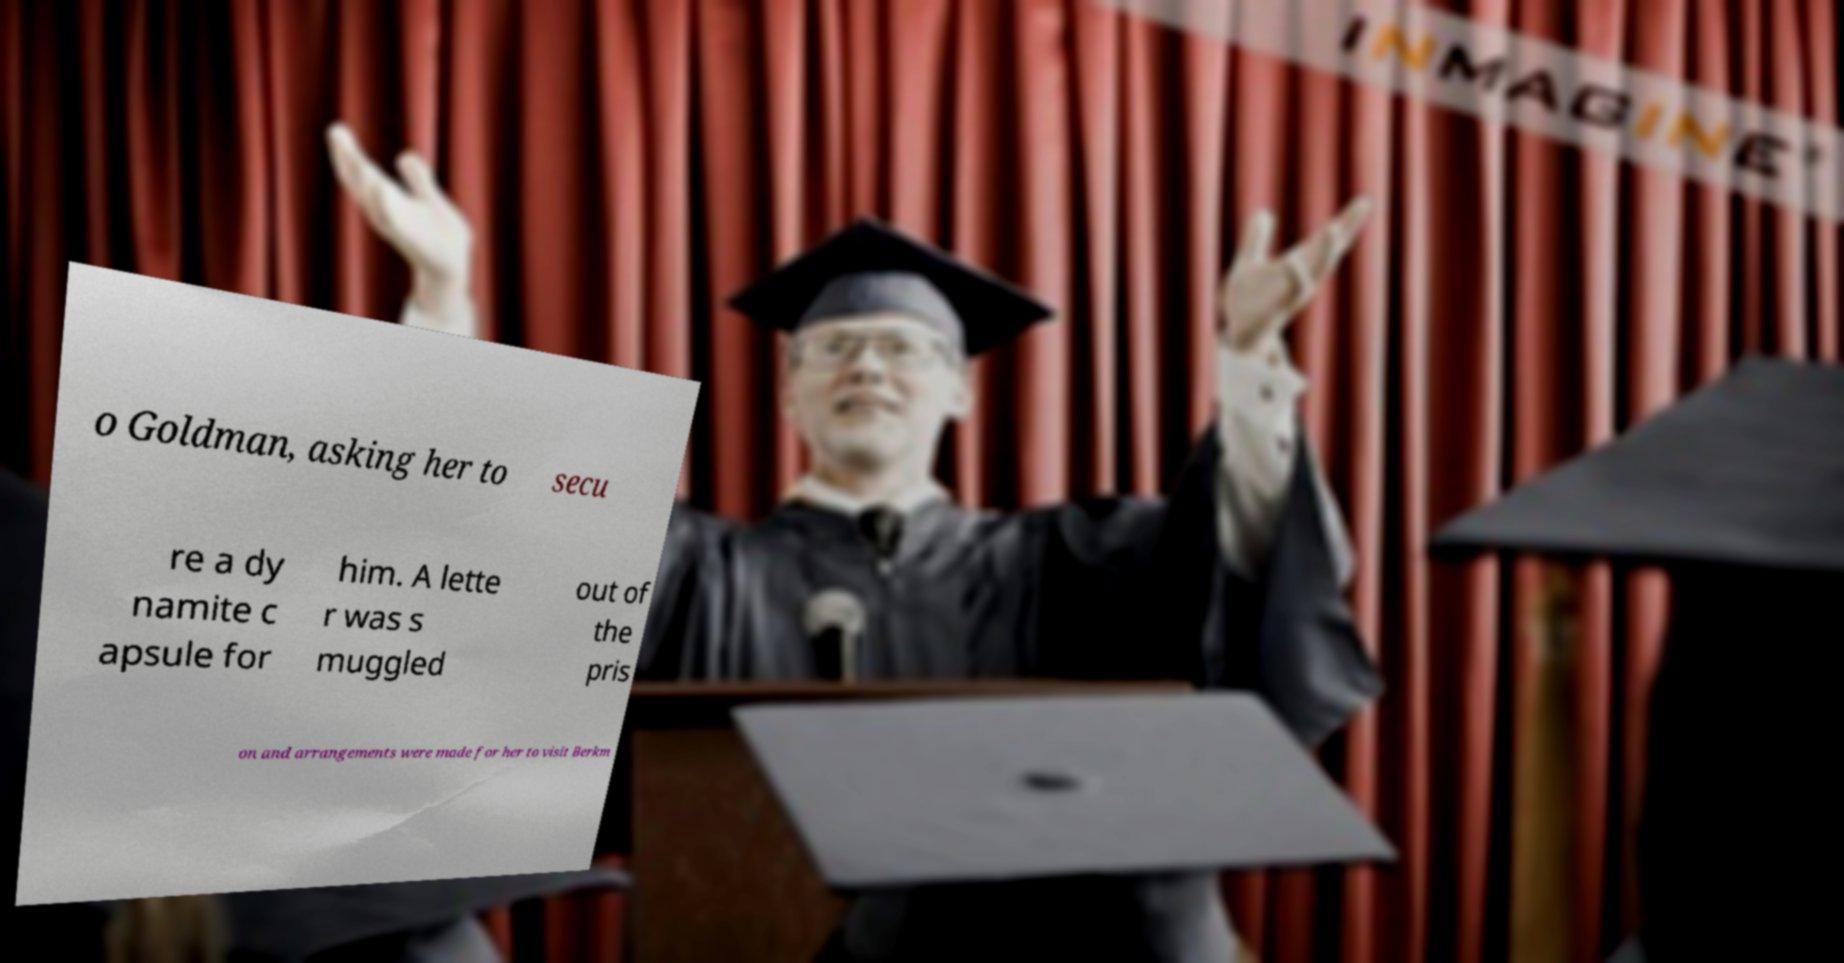Please read and relay the text visible in this image. What does it say? o Goldman, asking her to secu re a dy namite c apsule for him. A lette r was s muggled out of the pris on and arrangements were made for her to visit Berkm 